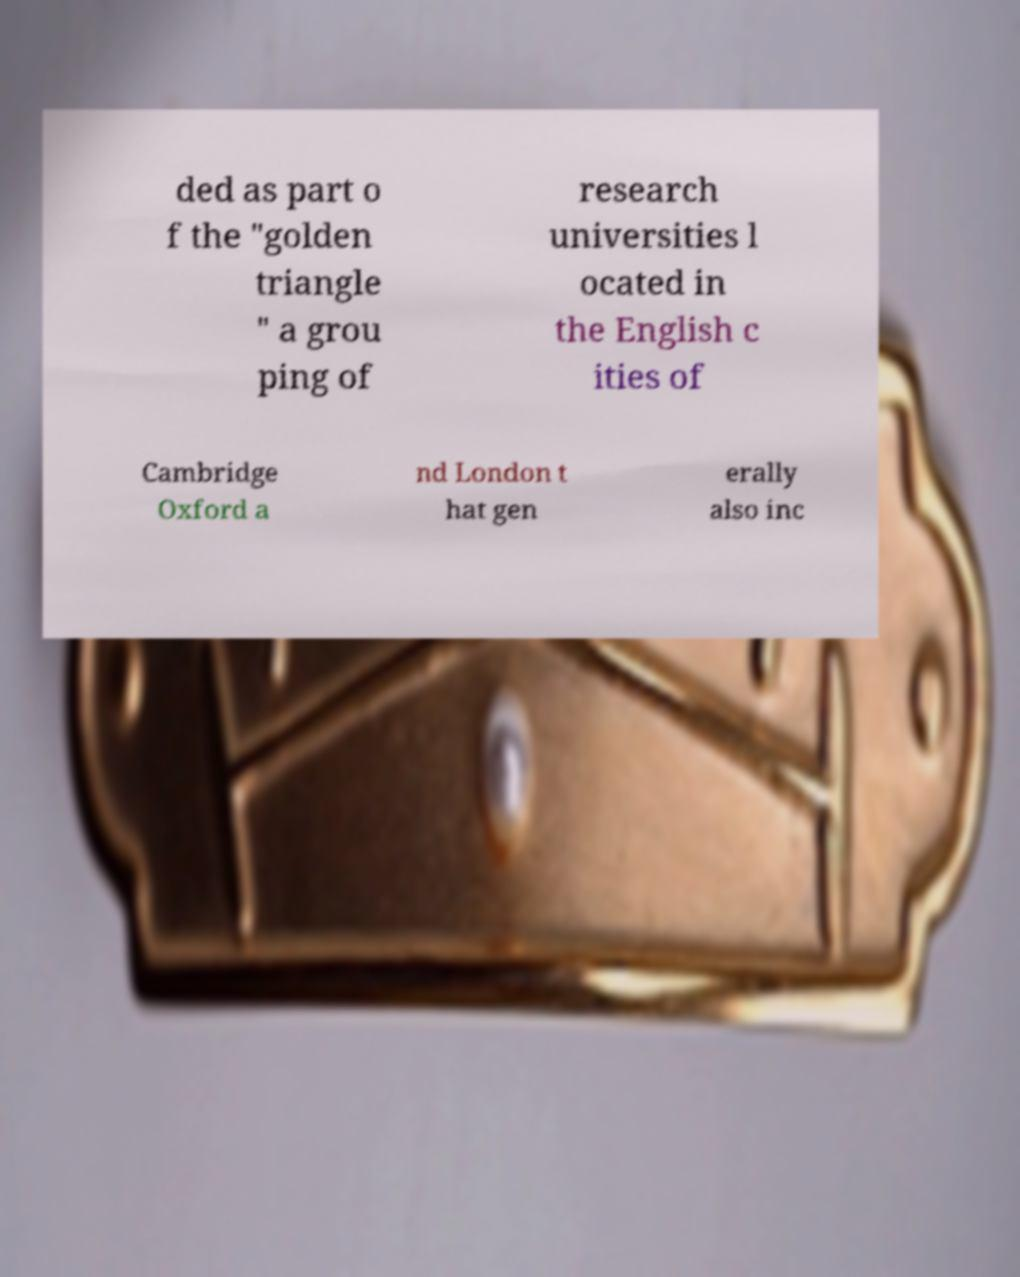Can you read and provide the text displayed in the image?This photo seems to have some interesting text. Can you extract and type it out for me? ded as part o f the "golden triangle " a grou ping of research universities l ocated in the English c ities of Cambridge Oxford a nd London t hat gen erally also inc 